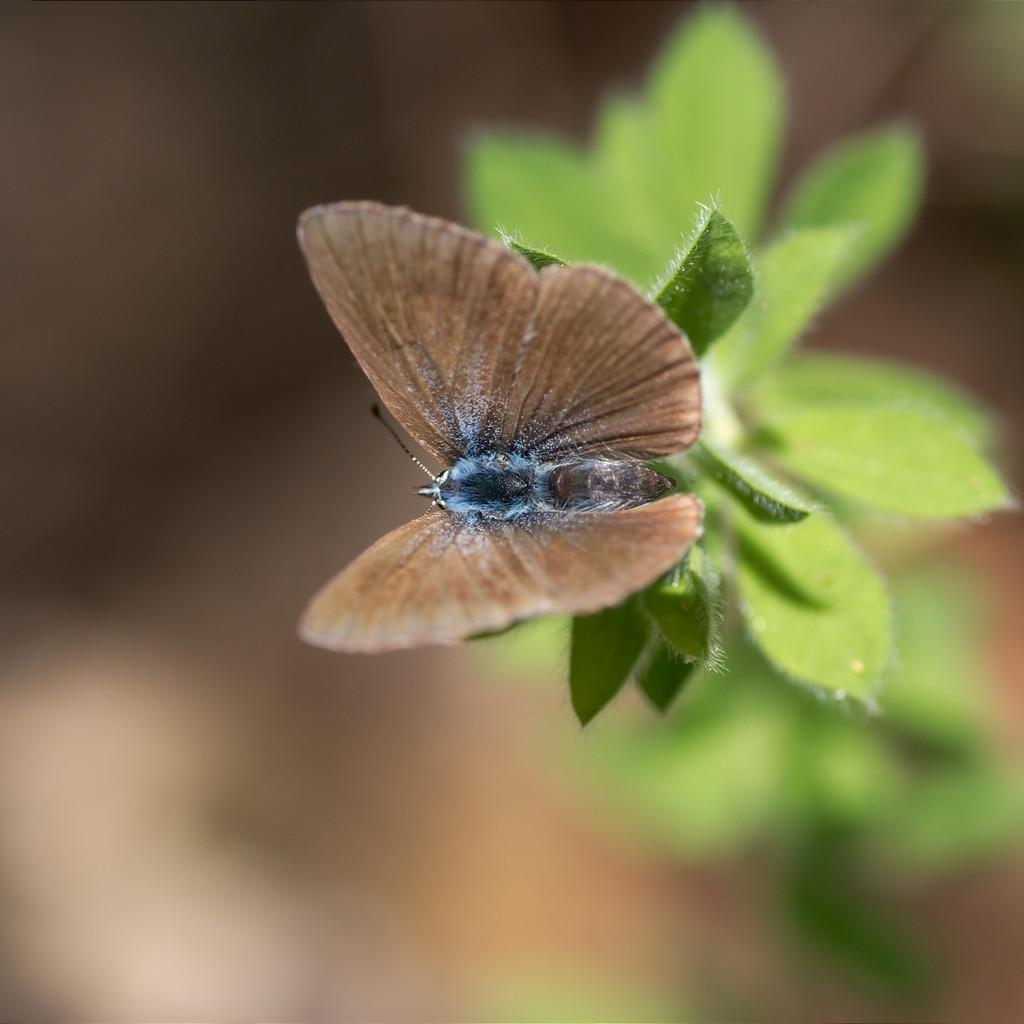Describe this image in one or two sentences. In this image there is a butterfly on the plant having few leaves. Butterfly is having brown colour wings. Background is blurry. 